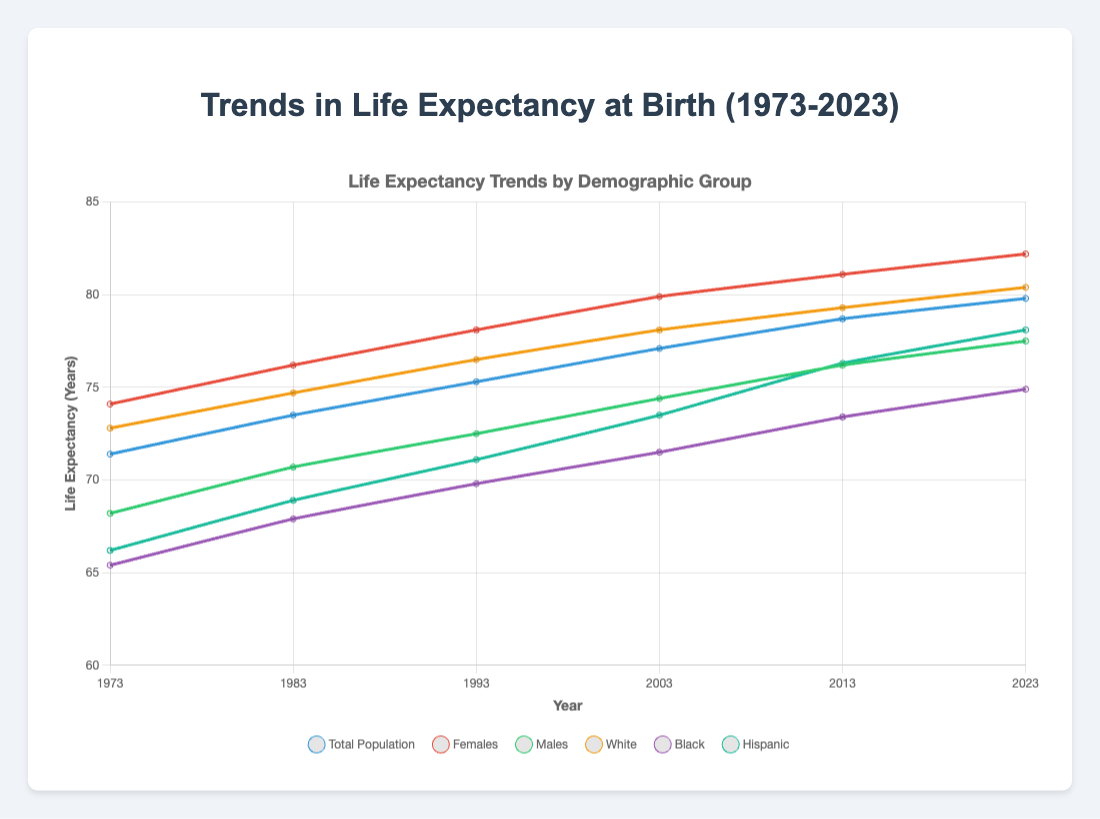Which demographic group had the highest life expectancy in 2023? According to the chart, females had the highest life expectancy in 2023, reaching 82.2 years.
Answer: Females What was the trend in life expectancy for the total population from 1973 to 2023? The life expectancy for the total population consistently increased from 71.4 years in 1973 to 79.8 years in 2023.
Answer: An upward trend By how many years did the life expectancy for Males increase from 1973 to 2023? In 1973, the life expectancy for males was 68.2 years, and in 2023, it was 77.5 years. The increase is 77.5 - 68.2 = 9.3 years.
Answer: 9.3 years Which group had a higher life expectancy in 1983: Black or Hispanic? In 1983, the life expectancy for the Black group was 67.9 years, while for the Hispanic group, it was 68.9 years. Hispanic had a higher life expectancy.
Answer: Hispanic How does the life expectancy of the White demographic group compare to the Total Population in 2023? In 2023, the life expectancy of the White group was 80.4 years, which is higher than the Total Population's life expectancy of 79.8 years.
Answer: Higher What is the average life expectancy of the Females demographic group across the years listed? To find the average, sum the values for Females (74.1, 76.2, 78.1, 79.9, 81.1, 82.2), which totals 471.6, and then divide by the number of years (6): 471.6 / 6 = 78.6.
Answer: 78.6 years What is the difference in life expectancy between Females and Males in 2013? In 2013, the life expectancies were:
- Females: 81.1 years
- Males: 76.2 years
The difference is 81.1 - 76.2 = 4.9 years.
Answer: 4.9 years Which demographic group had the lowest life expectancy in 1973, and what was it? In 1973, the Black demographic group had the lowest life expectancy at 65.4 years.
Answer: Black, 65.4 years 